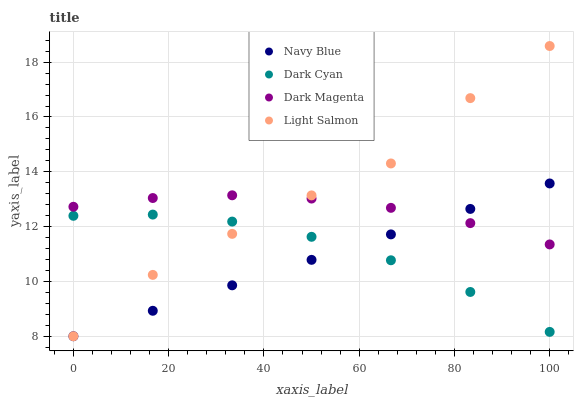Does Navy Blue have the minimum area under the curve?
Answer yes or no. Yes. Does Light Salmon have the maximum area under the curve?
Answer yes or no. Yes. Does Light Salmon have the minimum area under the curve?
Answer yes or no. No. Does Navy Blue have the maximum area under the curve?
Answer yes or no. No. Is Navy Blue the smoothest?
Answer yes or no. Yes. Is Light Salmon the roughest?
Answer yes or no. Yes. Is Light Salmon the smoothest?
Answer yes or no. No. Is Navy Blue the roughest?
Answer yes or no. No. Does Navy Blue have the lowest value?
Answer yes or no. Yes. Does Dark Magenta have the lowest value?
Answer yes or no. No. Does Light Salmon have the highest value?
Answer yes or no. Yes. Does Navy Blue have the highest value?
Answer yes or no. No. Is Dark Cyan less than Dark Magenta?
Answer yes or no. Yes. Is Dark Magenta greater than Dark Cyan?
Answer yes or no. Yes. Does Navy Blue intersect Dark Cyan?
Answer yes or no. Yes. Is Navy Blue less than Dark Cyan?
Answer yes or no. No. Is Navy Blue greater than Dark Cyan?
Answer yes or no. No. Does Dark Cyan intersect Dark Magenta?
Answer yes or no. No. 